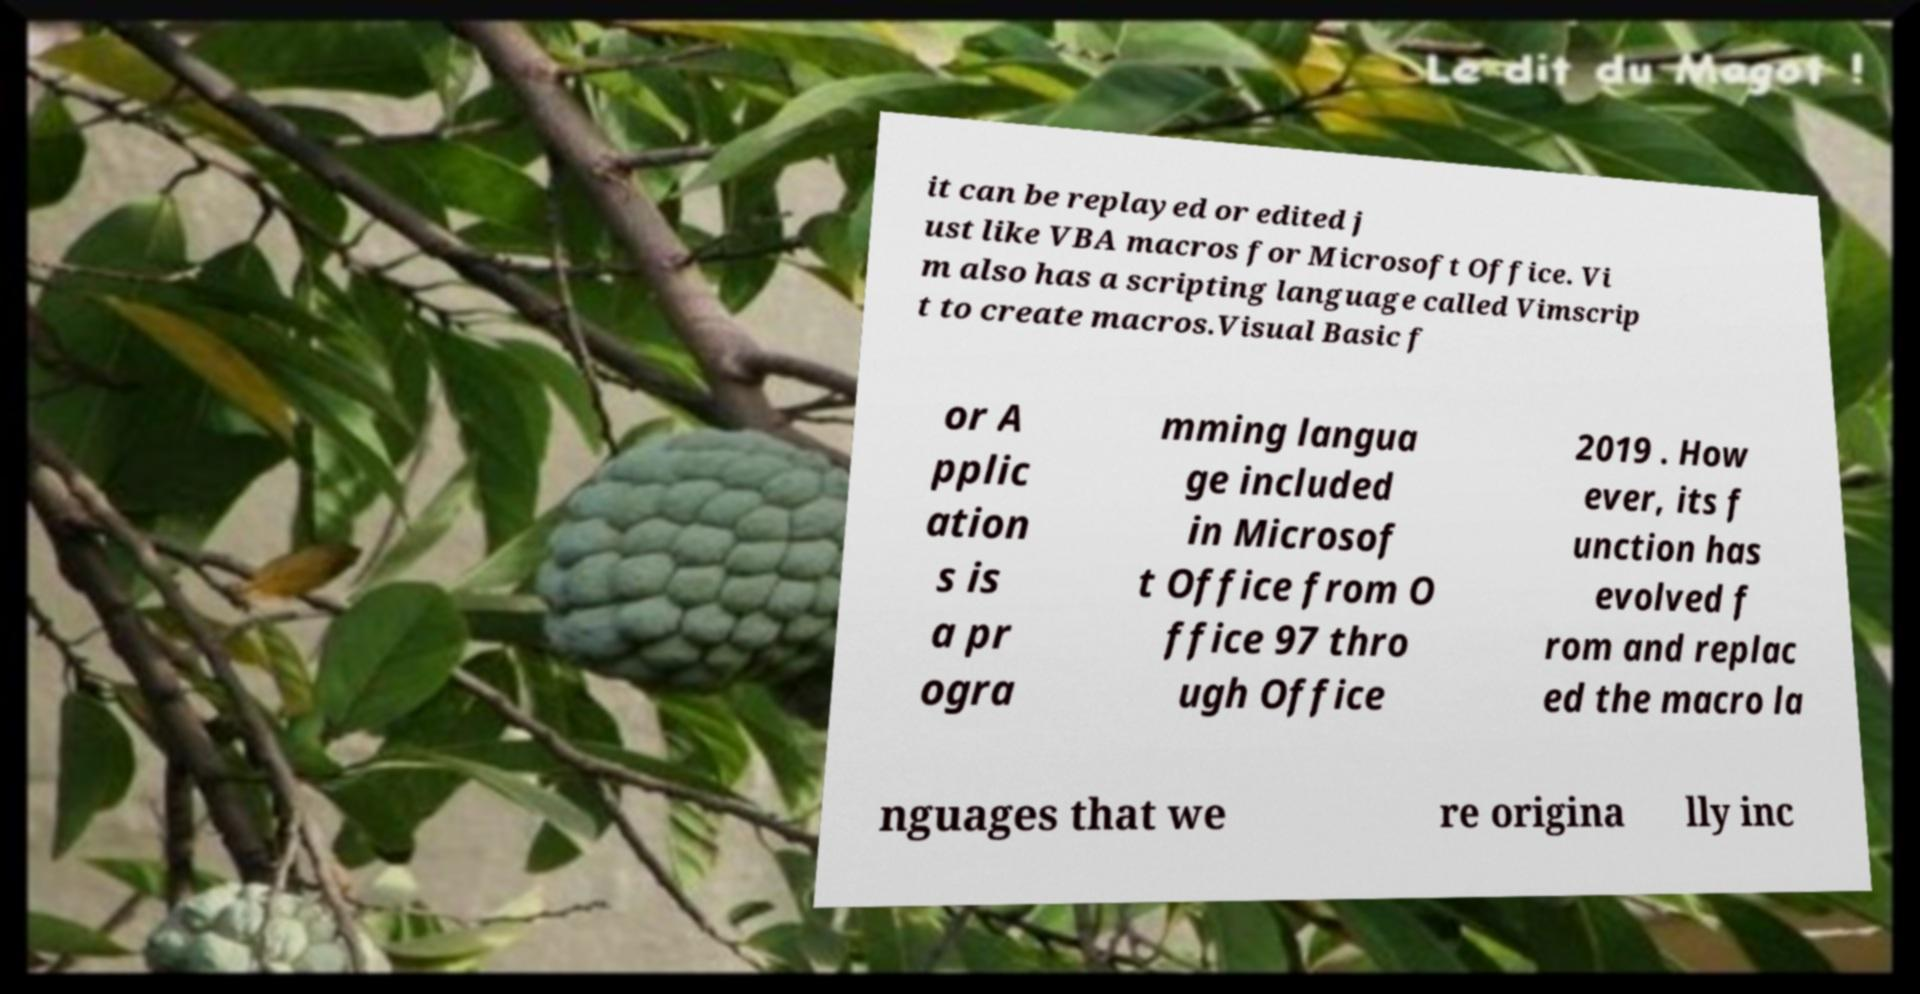Could you extract and type out the text from this image? it can be replayed or edited j ust like VBA macros for Microsoft Office. Vi m also has a scripting language called Vimscrip t to create macros.Visual Basic f or A pplic ation s is a pr ogra mming langua ge included in Microsof t Office from O ffice 97 thro ugh Office 2019 . How ever, its f unction has evolved f rom and replac ed the macro la nguages that we re origina lly inc 